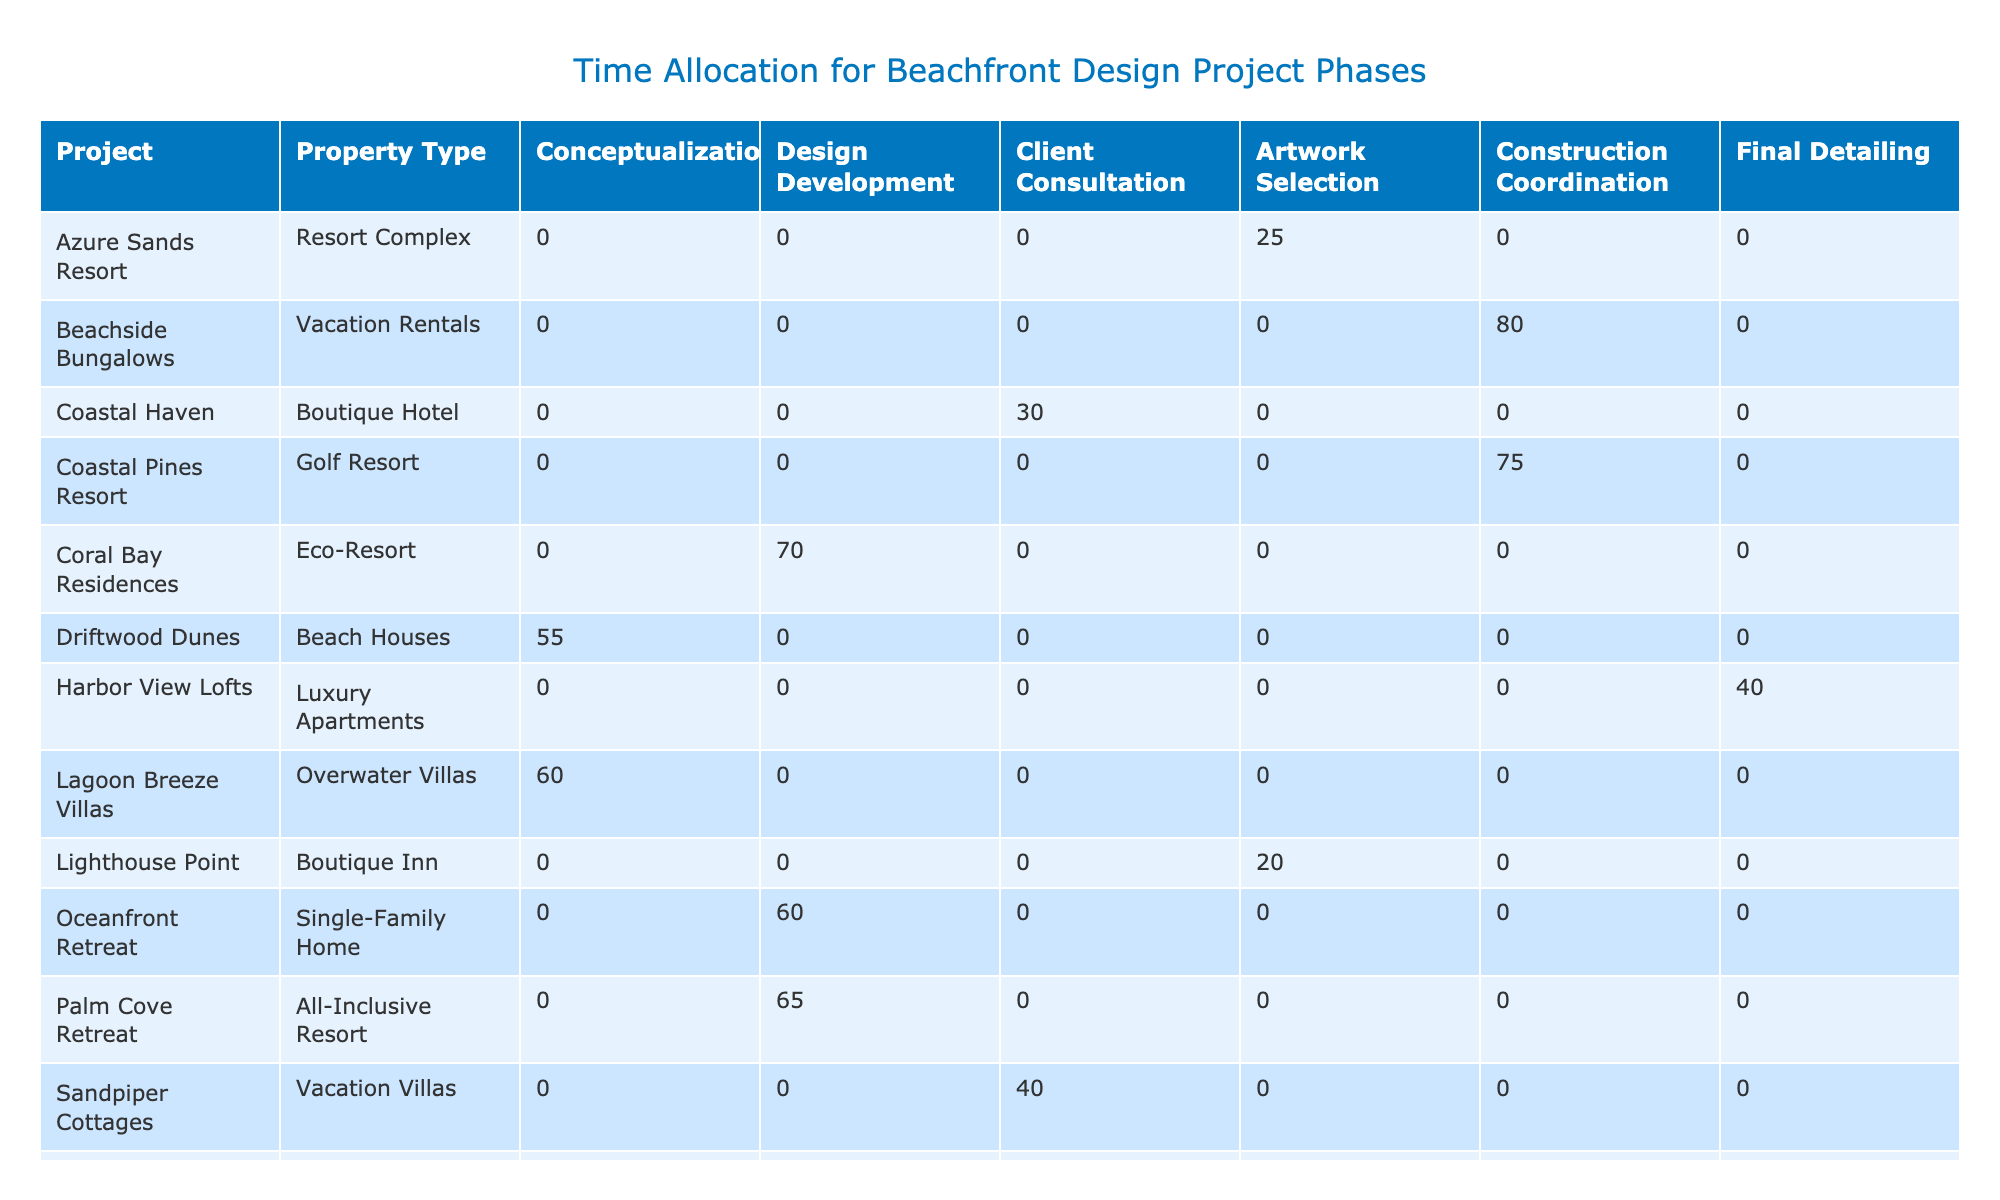What is the total time allocation for the Construction Coordination phase across all projects? To find the total time allocation for the Construction Coordination phase, we can look at the respective values for this phase in the table. The total is calculated as follows: 80 (Beachside Bungalows) + 90 (Tidal Breeze Condos) + 75 (Coastal Pines Resort) = 245 hours.
Answer: 245 Which project has the highest time allocation for the Design Development phase? The Design Development phase values in the table are as follows: 60 hours for Oceanfront Retreat and 65 hours for Palm Cove Retreat. The highest value is therefore 80 hours for Seastar Residences.
Answer: Seastar Residences Is there any project that allocates time for all six phases of design? A project must have non-zero time allocations for each of the six phases to satisfy this condition. Upon examining the data, no project includes allocations for all phases, as at least one project phase is zero for every row.
Answer: No What is the average time allocated for the Client Consultation phase across all projects? The Client Consultation phase allocations from the table are: 30 (Coastal Haven), 40 (Sandpiper Cottages), and 35 (Seagrass Sanctuary). First, we calculate the sum: 30 + 40 + 35 = 105. There are 3 projects, so the average is 105 / 3 = 35 hours.
Answer: 35 How many hours are allocated in total for the Final Detailing phase? Summing up the time allocated for the Final Detailing phase across the relevant projects, we find: 35 (Seashell Suites) + 30 (Sunset Cliffs Estate) + 40 (Harbor View Lofts) = 105 hours.
Answer: 105 Which two artists contributed to the highest time allocations for the Artwork Selection phase? The times allocated in the Artwork Selection phase are: 25 hours (Azure Sands Resort), 20 hours (Lighthouse Point), and 30 hours (Surfside Inn). The two maximum allocations are 30 (Surfside Inn) and 25 (Azure Sands Resort) by Robert Garcia and Michael Torres.
Answer: Robert Garcia and Michael Torres Does any property type have a total allocation greater than 300 hours when aggregating all project phases? To determine this, we sum the time allocations for each property type. By analyzing the data, we find that no single property type exceeds 300 total hours across its projects, since the highest summed project type (Vacations Rentals + Eco-Resort + Luxury Mansion) equals 285 hours.
Answer: No What is the total time allocation for projects under “Luxury Condo” property type? The relevant rows for Luxury Condo are: Seaside Villas (45 hours) and Waves Edge Manor (50 hours). Summing these yields: 45 + 50 = 95 hours.
Answer: 95 Identify the project with the least time allocation in the Artwork Selection phase. The projects and their values for Artwork Selection are: 25 (Azure Sands Resort), 20 (Lighthouse Point), and 30 (Surfside Inn). The minimum value is 20 hours from Lighthouse Point.
Answer: Lighthouse Point 